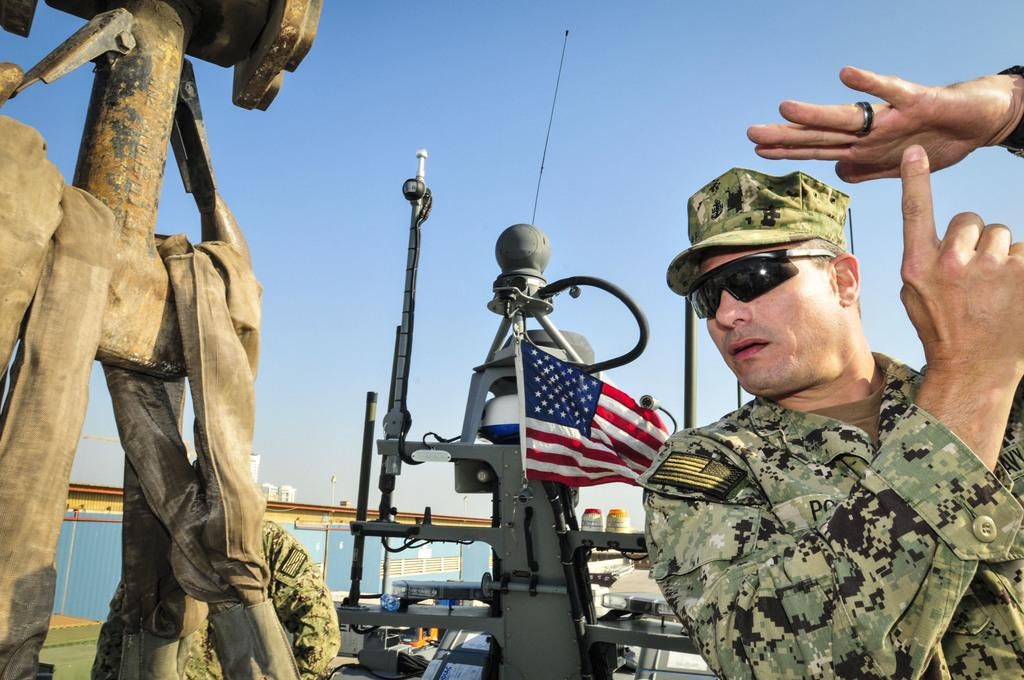How many people are present in the image? There are two persons in the image. What type of objects can be seen in the image? There are mechanical instruments in the image. What is the background of the image? There is a wall in the image. What is the symbolic object in the image? There is a flag in the image. What type of structures are visible in the image? There are houses in the image. What is visible in the upper part of the image? The sky is visible in the image. Can you see any fangs in the image? There are no fangs present in the image. Is there a lake visible in the image? There is no lake present in the image. 